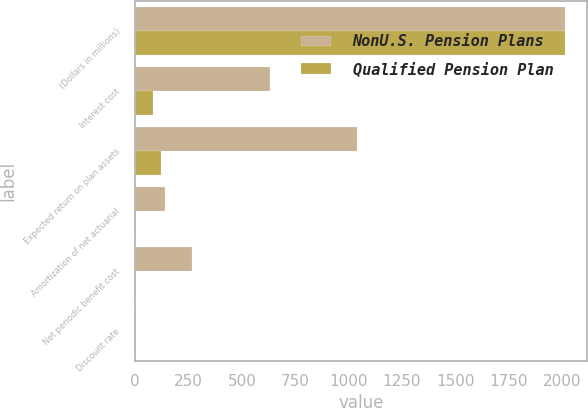<chart> <loc_0><loc_0><loc_500><loc_500><stacked_bar_chart><ecel><fcel>(Dollars in millions)<fcel>Interest cost<fcel>Expected return on plan assets<fcel>Amortization of net actuarial<fcel>Net periodic benefit cost<fcel>Discount rate<nl><fcel>NonU.S. Pension Plans<fcel>2016<fcel>634<fcel>1038<fcel>139<fcel>265<fcel>4.51<nl><fcel>Qualified Pension Plan<fcel>2016<fcel>86<fcel>123<fcel>6<fcel>4<fcel>3.59<nl></chart> 